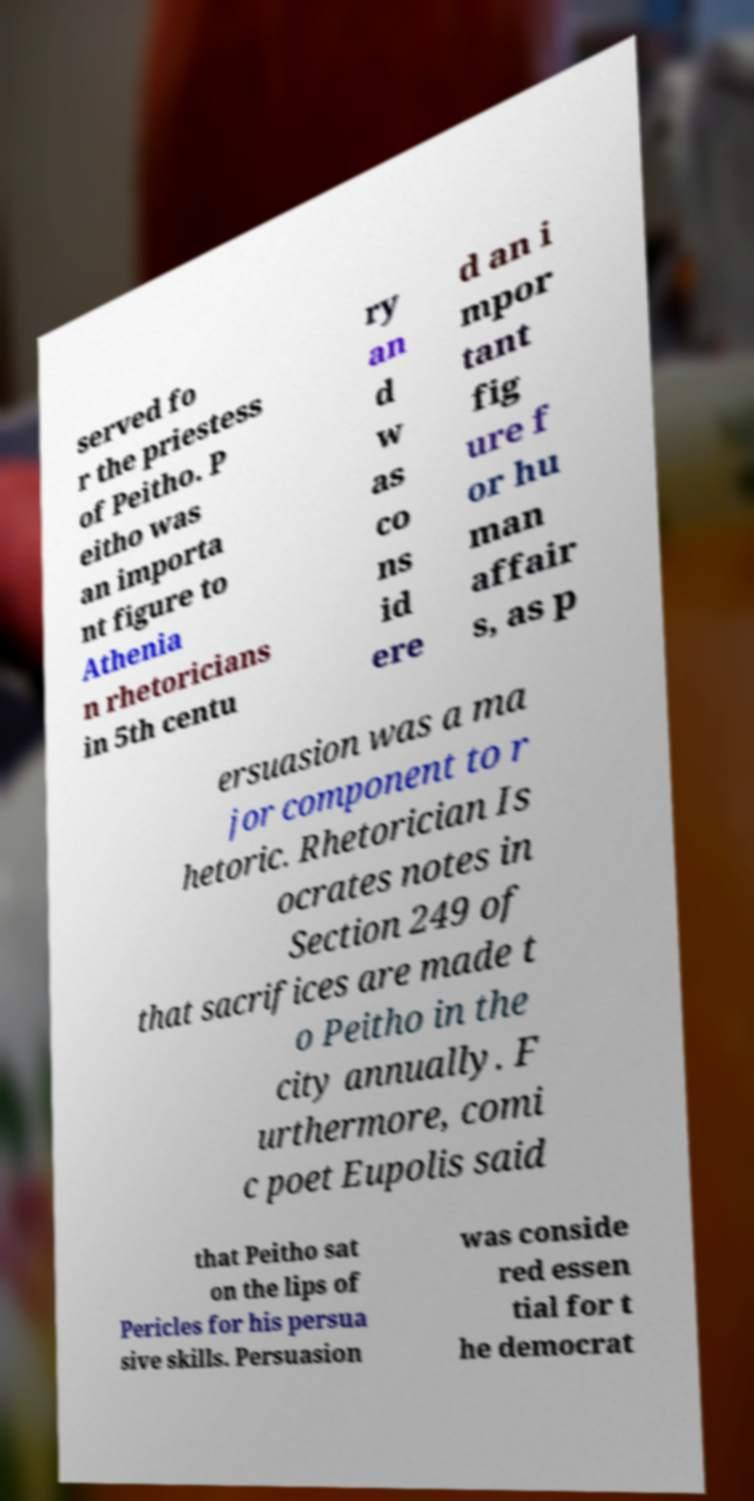Could you assist in decoding the text presented in this image and type it out clearly? served fo r the priestess of Peitho. P eitho was an importa nt figure to Athenia n rhetoricians in 5th centu ry an d w as co ns id ere d an i mpor tant fig ure f or hu man affair s, as p ersuasion was a ma jor component to r hetoric. Rhetorician Is ocrates notes in Section 249 of that sacrifices are made t o Peitho in the city annually. F urthermore, comi c poet Eupolis said that Peitho sat on the lips of Pericles for his persua sive skills. Persuasion was conside red essen tial for t he democrat 